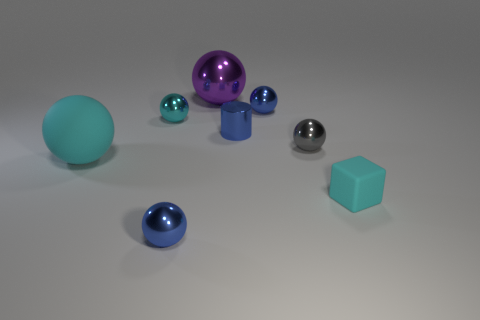Subtract all blue spheres. How many were subtracted if there are1blue spheres left? 1 Subtract all purple cubes. How many cyan spheres are left? 2 Subtract all blue spheres. How many spheres are left? 4 Add 1 tiny blue cylinders. How many objects exist? 9 Subtract all cyan balls. How many balls are left? 4 Subtract all yellow spheres. Subtract all gray blocks. How many spheres are left? 6 Subtract all cubes. How many objects are left? 7 Subtract all small green rubber spheres. Subtract all blue things. How many objects are left? 5 Add 5 small metal cylinders. How many small metal cylinders are left? 6 Add 5 big cyan things. How many big cyan things exist? 6 